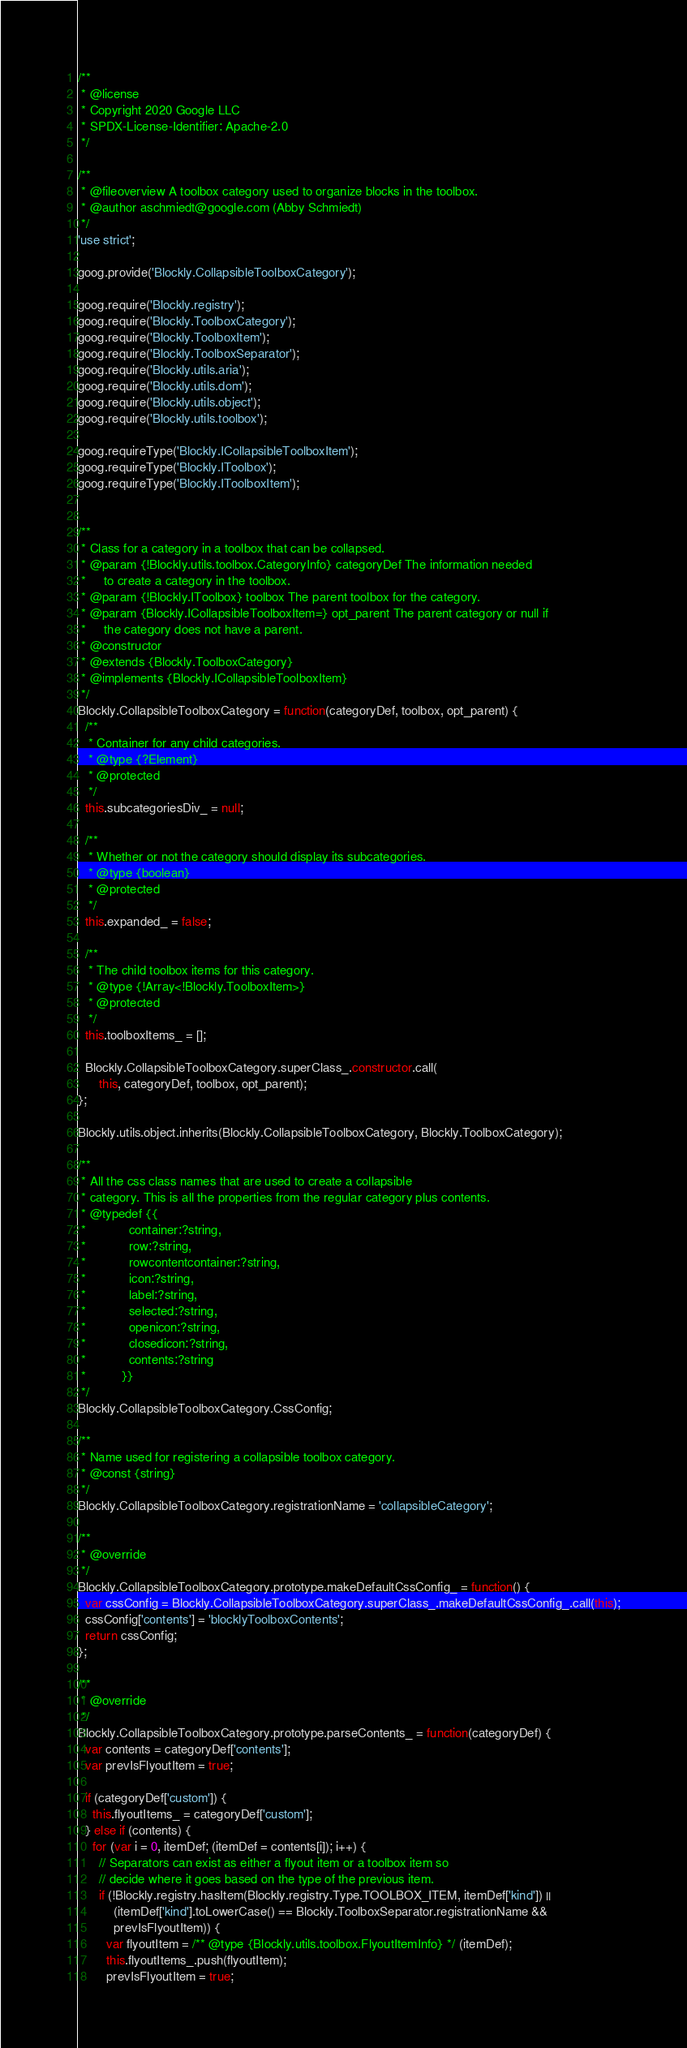Convert code to text. <code><loc_0><loc_0><loc_500><loc_500><_JavaScript_>/**
 * @license
 * Copyright 2020 Google LLC
 * SPDX-License-Identifier: Apache-2.0
 */

/**
 * @fileoverview A toolbox category used to organize blocks in the toolbox.
 * @author aschmiedt@google.com (Abby Schmiedt)
 */
'use strict';

goog.provide('Blockly.CollapsibleToolboxCategory');

goog.require('Blockly.registry');
goog.require('Blockly.ToolboxCategory');
goog.require('Blockly.ToolboxItem');
goog.require('Blockly.ToolboxSeparator');
goog.require('Blockly.utils.aria');
goog.require('Blockly.utils.dom');
goog.require('Blockly.utils.object');
goog.require('Blockly.utils.toolbox');

goog.requireType('Blockly.ICollapsibleToolboxItem');
goog.requireType('Blockly.IToolbox');
goog.requireType('Blockly.IToolboxItem');


/**
 * Class for a category in a toolbox that can be collapsed.
 * @param {!Blockly.utils.toolbox.CategoryInfo} categoryDef The information needed
 *     to create a category in the toolbox.
 * @param {!Blockly.IToolbox} toolbox The parent toolbox for the category.
 * @param {Blockly.ICollapsibleToolboxItem=} opt_parent The parent category or null if
 *     the category does not have a parent.
 * @constructor
 * @extends {Blockly.ToolboxCategory}
 * @implements {Blockly.ICollapsibleToolboxItem}
 */
Blockly.CollapsibleToolboxCategory = function(categoryDef, toolbox, opt_parent) {
  /**
   * Container for any child categories.
   * @type {?Element}
   * @protected
   */
  this.subcategoriesDiv_ = null;

  /**
   * Whether or not the category should display its subcategories.
   * @type {boolean}
   * @protected
   */
  this.expanded_ = false;

  /**
   * The child toolbox items for this category.
   * @type {!Array<!Blockly.ToolboxItem>}
   * @protected
   */
  this.toolboxItems_ = [];

  Blockly.CollapsibleToolboxCategory.superClass_.constructor.call(
      this, categoryDef, toolbox, opt_parent);
};

Blockly.utils.object.inherits(Blockly.CollapsibleToolboxCategory, Blockly.ToolboxCategory);

/**
 * All the css class names that are used to create a collapsible
 * category. This is all the properties from the regular category plus contents.
 * @typedef {{
 *            container:?string,
 *            row:?string,
 *            rowcontentcontainer:?string,
 *            icon:?string,
 *            label:?string,
 *            selected:?string,
 *            openicon:?string,
 *            closedicon:?string,
 *            contents:?string
 *          }}
 */
Blockly.CollapsibleToolboxCategory.CssConfig;

/**
 * Name used for registering a collapsible toolbox category.
 * @const {string}
 */
Blockly.CollapsibleToolboxCategory.registrationName = 'collapsibleCategory';

/**
 * @override
 */
Blockly.CollapsibleToolboxCategory.prototype.makeDefaultCssConfig_ = function() {
  var cssConfig = Blockly.CollapsibleToolboxCategory.superClass_.makeDefaultCssConfig_.call(this);
  cssConfig['contents'] = 'blocklyToolboxContents';
  return cssConfig;
};

/**
 * @override
 */
Blockly.CollapsibleToolboxCategory.prototype.parseContents_ = function(categoryDef) {
  var contents = categoryDef['contents'];
  var prevIsFlyoutItem = true;

  if (categoryDef['custom']) {
    this.flyoutItems_ = categoryDef['custom'];
  } else if (contents) {
    for (var i = 0, itemDef; (itemDef = contents[i]); i++) {
      // Separators can exist as either a flyout item or a toolbox item so
      // decide where it goes based on the type of the previous item.
      if (!Blockly.registry.hasItem(Blockly.registry.Type.TOOLBOX_ITEM, itemDef['kind']) ||
          (itemDef['kind'].toLowerCase() == Blockly.ToolboxSeparator.registrationName &&
          prevIsFlyoutItem)) {
        var flyoutItem = /** @type {Blockly.utils.toolbox.FlyoutItemInfo} */ (itemDef);
        this.flyoutItems_.push(flyoutItem);
        prevIsFlyoutItem = true;</code> 